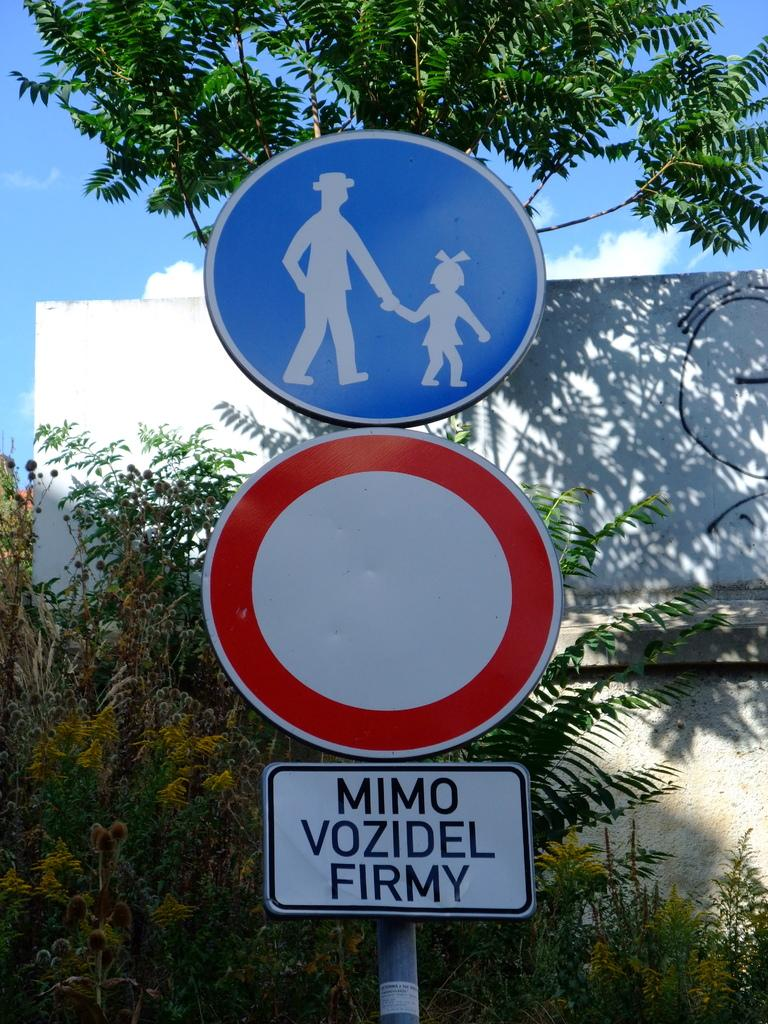What is the main subject in the center of the image? There is a sign board in the center of the image. What can be seen in the background of the image? There is a wall and trees in the background of the image. What type of insect can be seen crawling on the sign board in the image? There are no insects visible on the sign board in the image. 